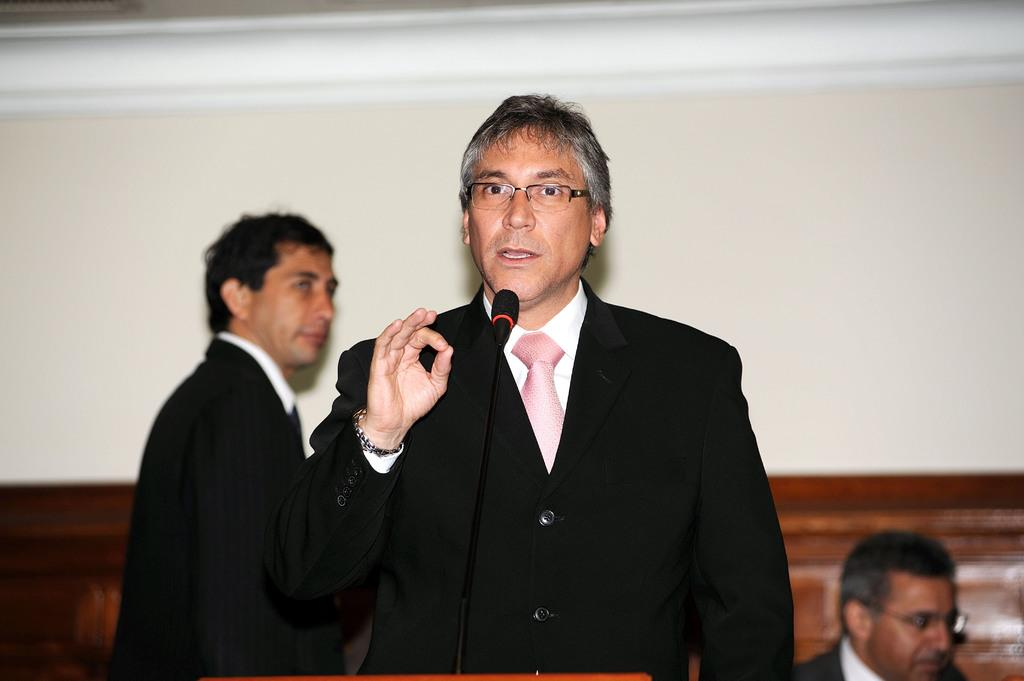Who or what can be seen in the image? There are people in the image. What object is present that is typically used for amplifying sound? There is a microphone in the image. What type of structure can be seen in the background of the image? There is a wall in the image. What color is the silver playground equipment in the image? There is no silver playground equipment present in the image. 